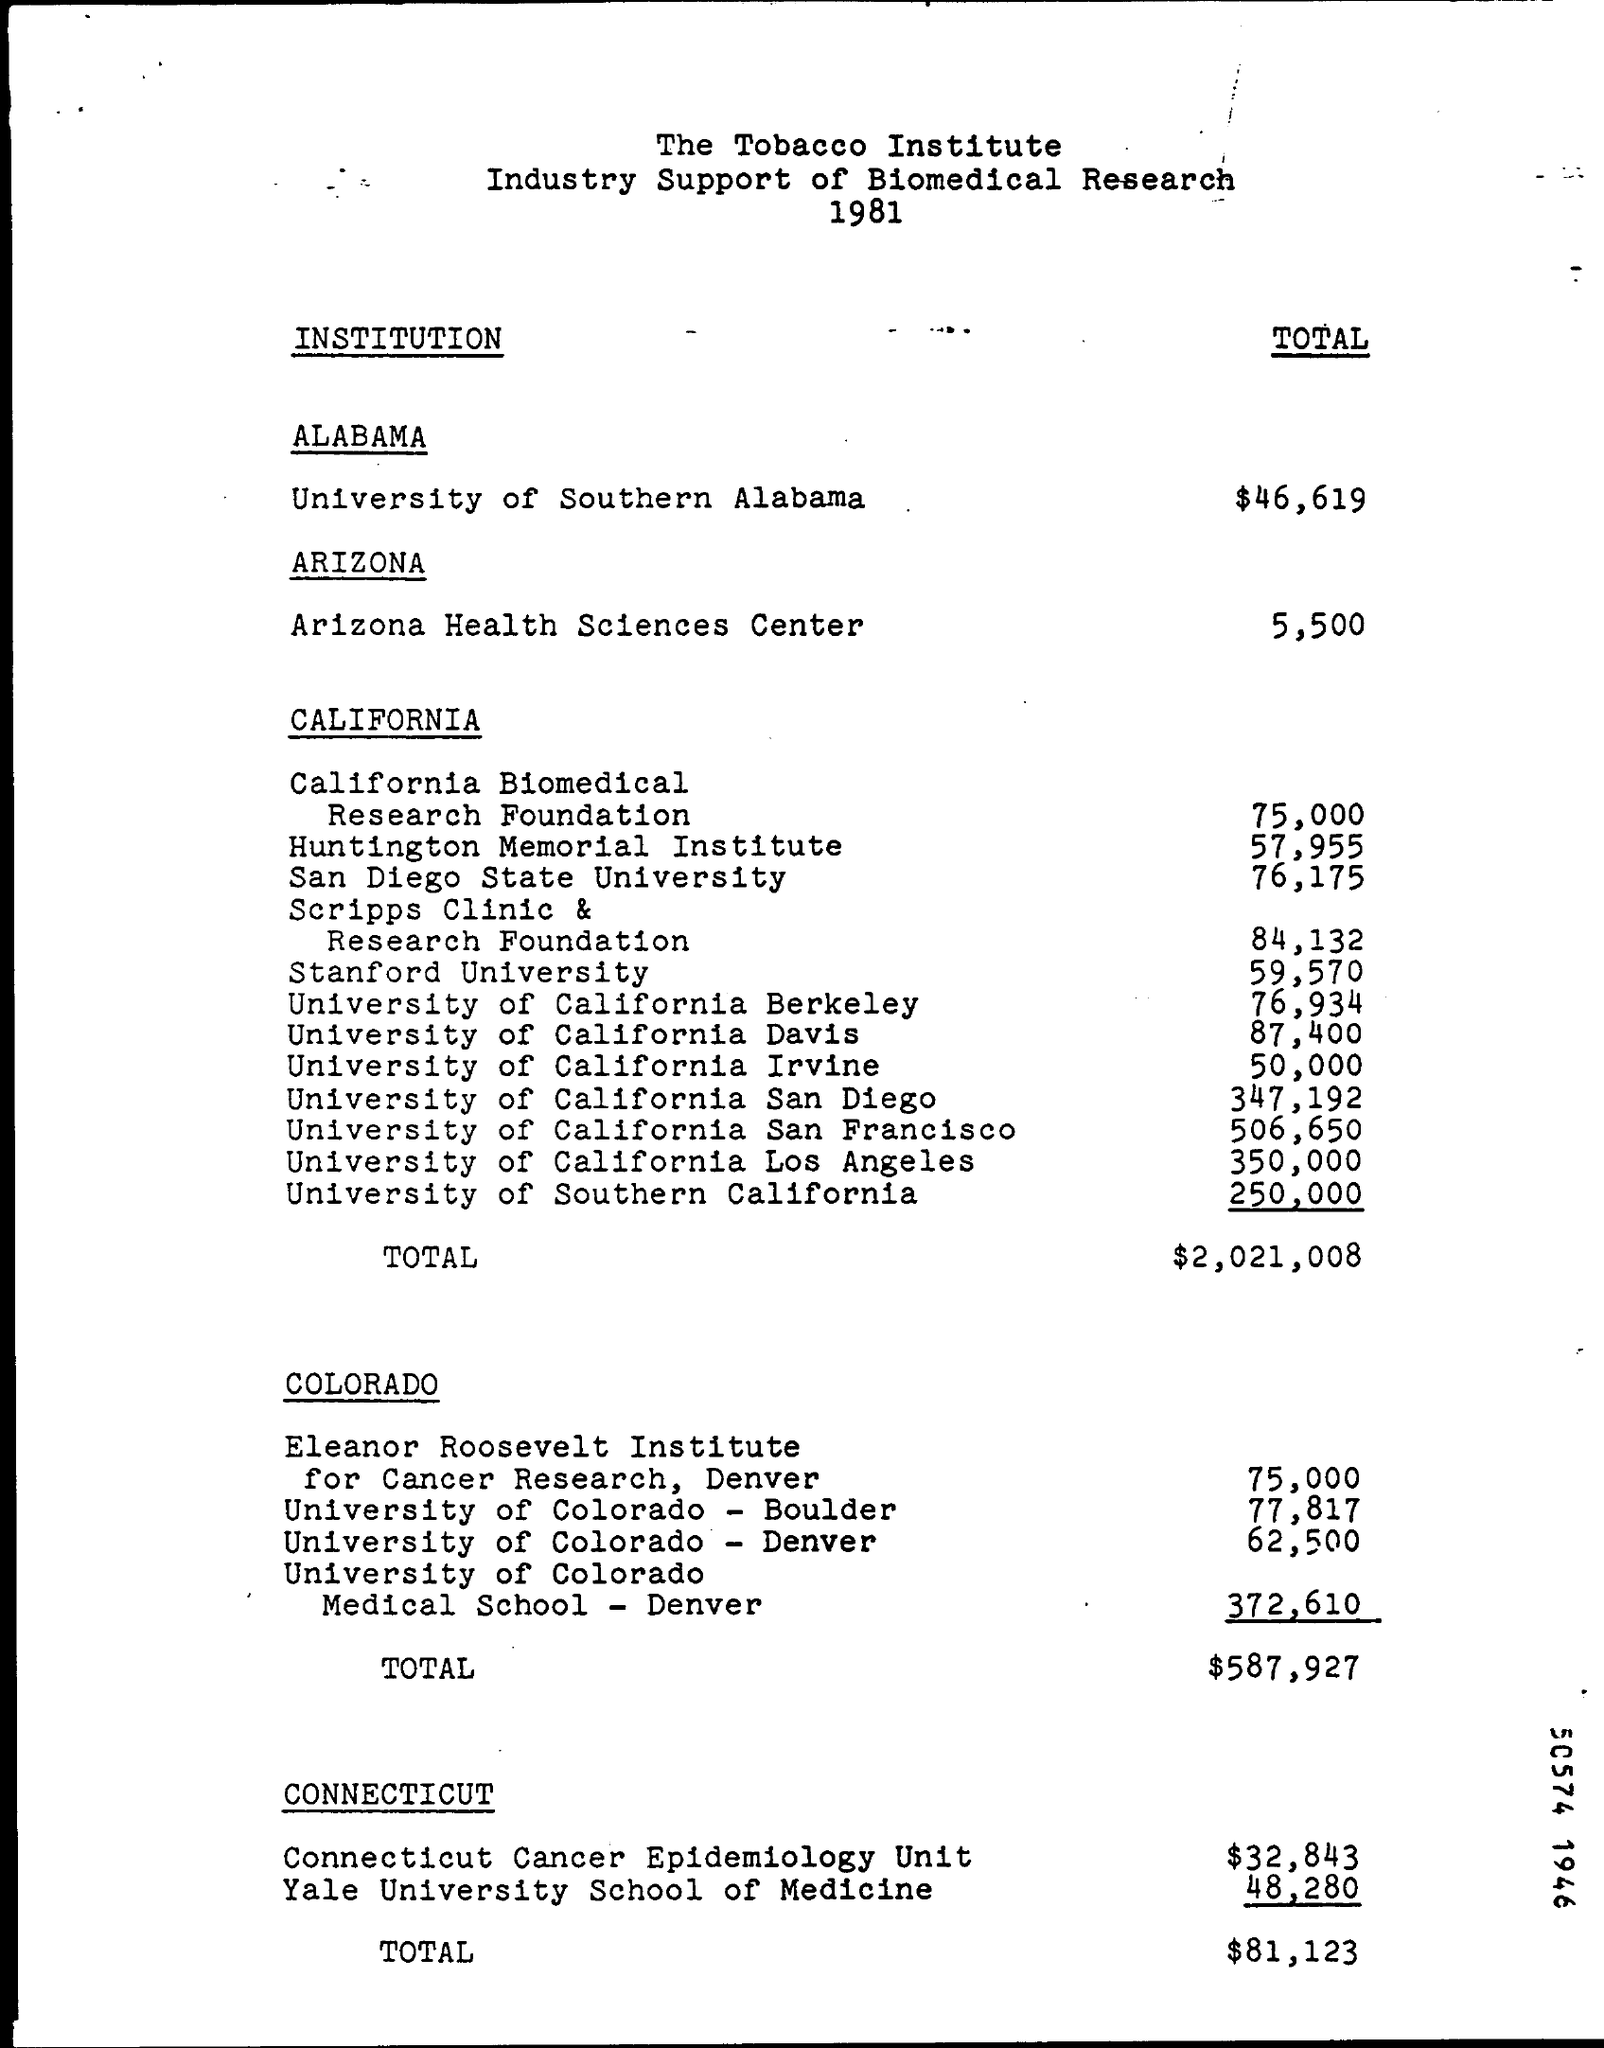What is the total amount given for university of southern alabama for biomedical research ?
Your answer should be very brief. $ 46,619. What is the total amount given for arizona health sciences center ?
Provide a short and direct response. 5,500. How much amount is given for california biomedical ?
Your response must be concise. 75,000. How much amount is given for university of southern california ?
Provide a succinct answer. 250,000. What is the total amount shown in california ?
Your answer should be very brief. $2,021,008. How much amount is given for eleanor roosevelt institute for cancer research ,denver ?
Make the answer very short. 75,000. What is the amount given for university of colorado-boulder ?
Offer a terse response. 77,817. What is the total amount in colorado ?
Your answer should be very brief. $587,927. How much amount is given for connecticut cancer epidemiology unit ?/
Keep it short and to the point. $ 32,843. How much amount is given for yale university school of medicine ?
Offer a very short reply. 48,280. 